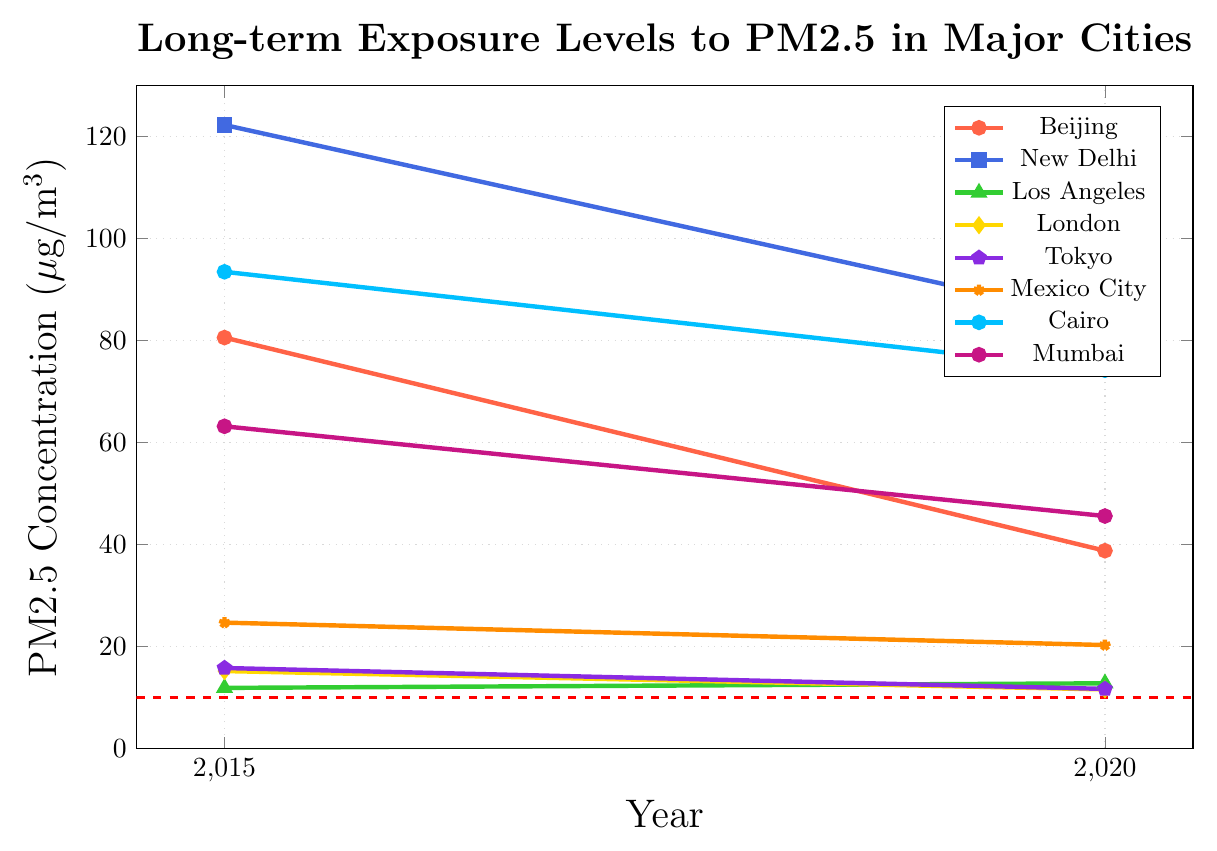What's the PM2.5 level in Beijing for the year 2015 and 2020, and did it increase or decrease? Beijing's PM2.5 level is marked with a red color and a round marker. The PM2.5 level for Beijing in 2015 is 80.6 µg/m³, and in 2020 it is 38.8 µg/m³. Since 38.8 is less than 80.6, the PM2.5 level decreased.
Answer: The PM2.5 level decreased Which city had the highest PM2.5 level in 2015? In 2015, the PM2.5 levels are 80.6, 122.3, 11.9, 15.2, 15.8, 24.7, 93.5, and 63.2 for Beijing, New Delhi, Los Angeles, London, Tokyo, Mexico City, Cairo, and Mumbai, respectively. Among these values, the highest is 122.3, which corresponds to New Delhi.
Answer: New Delhi How much did the PM2.5 level change in Cairo between 2015 and 2020? The PM2.5 level in Cairo is 93.5 µg/m³ in 2015 and 74.2 µg/m³ in 2020. The change is 93.5 - 74.2 = 19.3 µg/m³.
Answer: 19.3 µg/m³ Between Los Angeles and London, which city's PM2.5 level in 2020 is closer to the WHO guideline of 10 µg/m³? The PM2.5 level in 2020 for Los Angeles is 12.8 µg/m³ and for London is 11.6 µg/m³. The difference from the WHO guideline of 10 µg/m³ is 12.8 - 10 = 2.8 µg/m³ for Los Angeles and 11.6 - 10 = 1.6 µg/m³ for London. London is closer to the WHO guideline.
Answer: London List the cities where the PM2.5 level in 2020 is above the WHO guideline of 10 µg/m³. The PM2.5 levels in 2020 are 38.8, 84.1, 12.8, 11.6, 11.7, 20.3, 74.2, and 45.6 for Beijing, New Delhi, Los Angeles, London, Tokyo, Mexico City, Cairo, and Mumbai, respectively. All these values are above the WHO guideline of 10 µg/m³.
Answer: Beijing, New Delhi, Los Angeles, London, Tokyo, Mexico City, Cairo, Mumbai By how much did New Delhi's PM2.5 level decrease from 2015 to 2020? New Delhi's PM2.5 level in 2015 was 122.3 µg/m³, and in 2020 it was 84.1 µg/m³. The decrease is 122.3 - 84.1 = 38.2 µg/m³.
Answer: 38.2 µg/m³ Which city showed the least improvement in PM2.5 levels between 2015 and 2020? Los Angeles had a PM2.5 level of 11.9 µg/m³ in 2015 and 12.8 µg/m³ in 2020, indicating an increase rather than an improvement. Other cities showed a decrease. Therefore, Los Angeles showed the least improvement.
Answer: Los Angeles 